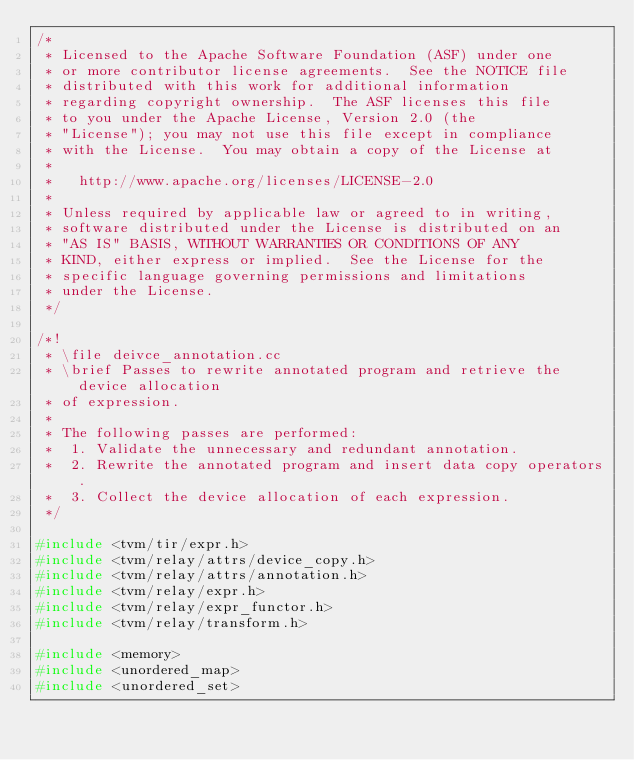<code> <loc_0><loc_0><loc_500><loc_500><_C++_>/*
 * Licensed to the Apache Software Foundation (ASF) under one
 * or more contributor license agreements.  See the NOTICE file
 * distributed with this work for additional information
 * regarding copyright ownership.  The ASF licenses this file
 * to you under the Apache License, Version 2.0 (the
 * "License"); you may not use this file except in compliance
 * with the License.  You may obtain a copy of the License at
 *
 *   http://www.apache.org/licenses/LICENSE-2.0
 *
 * Unless required by applicable law or agreed to in writing,
 * software distributed under the License is distributed on an
 * "AS IS" BASIS, WITHOUT WARRANTIES OR CONDITIONS OF ANY
 * KIND, either express or implied.  See the License for the
 * specific language governing permissions and limitations
 * under the License.
 */

/*!
 * \file deivce_annotation.cc
 * \brief Passes to rewrite annotated program and retrieve the device allocation
 * of expression.
 *
 * The following passes are performed:
 *  1. Validate the unnecessary and redundant annotation.
 *  2. Rewrite the annotated program and insert data copy operators.
 *  3. Collect the device allocation of each expression.
 */

#include <tvm/tir/expr.h>
#include <tvm/relay/attrs/device_copy.h>
#include <tvm/relay/attrs/annotation.h>
#include <tvm/relay/expr.h>
#include <tvm/relay/expr_functor.h>
#include <tvm/relay/transform.h>

#include <memory>
#include <unordered_map>
#include <unordered_set>
</code> 